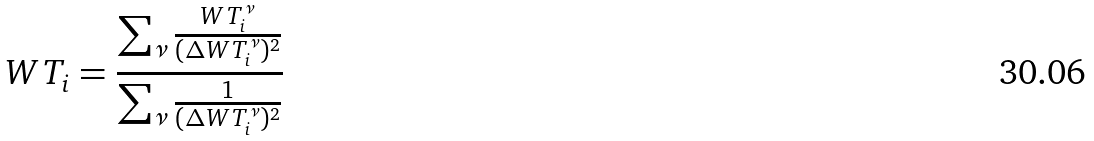<formula> <loc_0><loc_0><loc_500><loc_500>W T _ { i } = \frac { \sum _ { \nu } \frac { W T _ { i } ^ { \nu } } { ( \Delta W T _ { i } ^ { \nu } ) ^ { 2 } } } { \sum _ { \nu } \frac { 1 } { ( \Delta W T _ { i } ^ { \nu } ) ^ { 2 } } }</formula> 